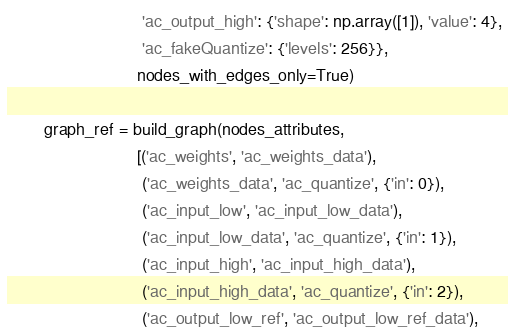<code> <loc_0><loc_0><loc_500><loc_500><_Python_>                             'ac_output_high': {'shape': np.array([1]), 'value': 4},
                             'ac_fakeQuantize': {'levels': 256}},
                            nodes_with_edges_only=True)

        graph_ref = build_graph(nodes_attributes,
                            [('ac_weights', 'ac_weights_data'),
                             ('ac_weights_data', 'ac_quantize', {'in': 0}),
                             ('ac_input_low', 'ac_input_low_data'),
                             ('ac_input_low_data', 'ac_quantize', {'in': 1}),
                             ('ac_input_high', 'ac_input_high_data'),
                             ('ac_input_high_data', 'ac_quantize', {'in': 2}),
                             ('ac_output_low_ref', 'ac_output_low_ref_data'),</code> 